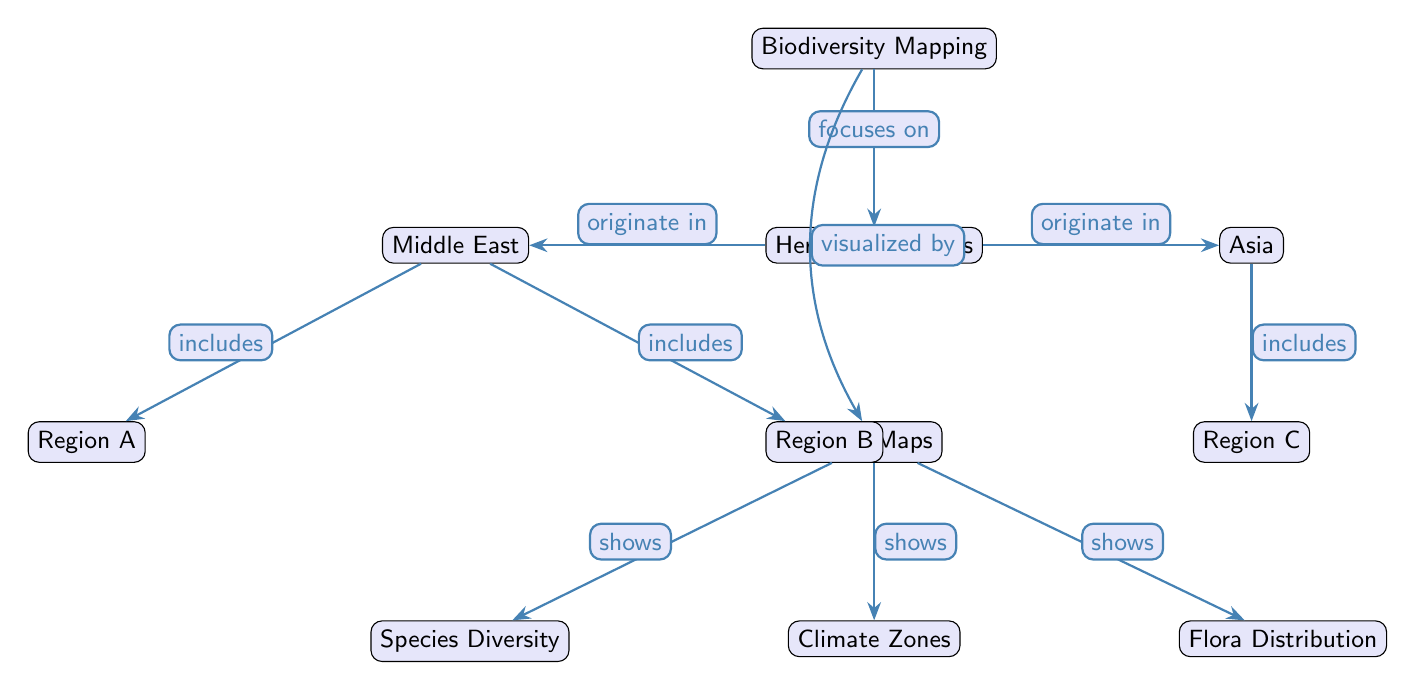What is the main focus of the diagram? The main focus of the diagram is indicated by the first node, which is "Biodiversity Mapping."
Answer: Biodiversity Mapping Which regions are associated with herbaceous plants? The regions associated with herbaceous plants are represented by the nodes under "Herbaceous Plants," which are the Middle East and Asia.
Answer: Middle East, Asia How many regions are labeled under Asia? There is one region labeled under Asia in the diagram, which is "Region C."
Answer: 1 What does the diagram visualize? The diagram visualizes biodiversity mapping of herbaceous plants using heat maps, as indicated by the node "Heat Maps."
Answer: Heat Maps Which aspect of biodiversity mapping does "Heat Maps" show? The "Heat Maps" node shows species diversity, climate zones, and flora distribution, as indicated by the edges leading to those nodes.
Answer: Species Diversity, Climate Zones, Flora Distribution What does the Middle East region include? The Middle East region includes two regions specifically labeled as "Region A" and "Region B."
Answer: Region A, Region B Which node is focused on herbaceous plants? The node that focuses on herbaceous plants is connected directly to the "Biodiversity Mapping" node, which states "Herbaceous Plants."
Answer: Herbaceous Plants What connections does "Heat Maps" have? The "Heat Maps" node has connections labeled as "shows" to three different nodes: Species Diversity, Climate Zones, and Flora Distribution.
Answer: Species Diversity, Climate Zones, Flora Distribution What is the relationship between "Herbaceous Plants" and the Middle East? The relationship between "Herbaceous Plants" and the Middle East is indicated by the edge stating that herbaceous plants "originate in" the Middle East.
Answer: originate in 